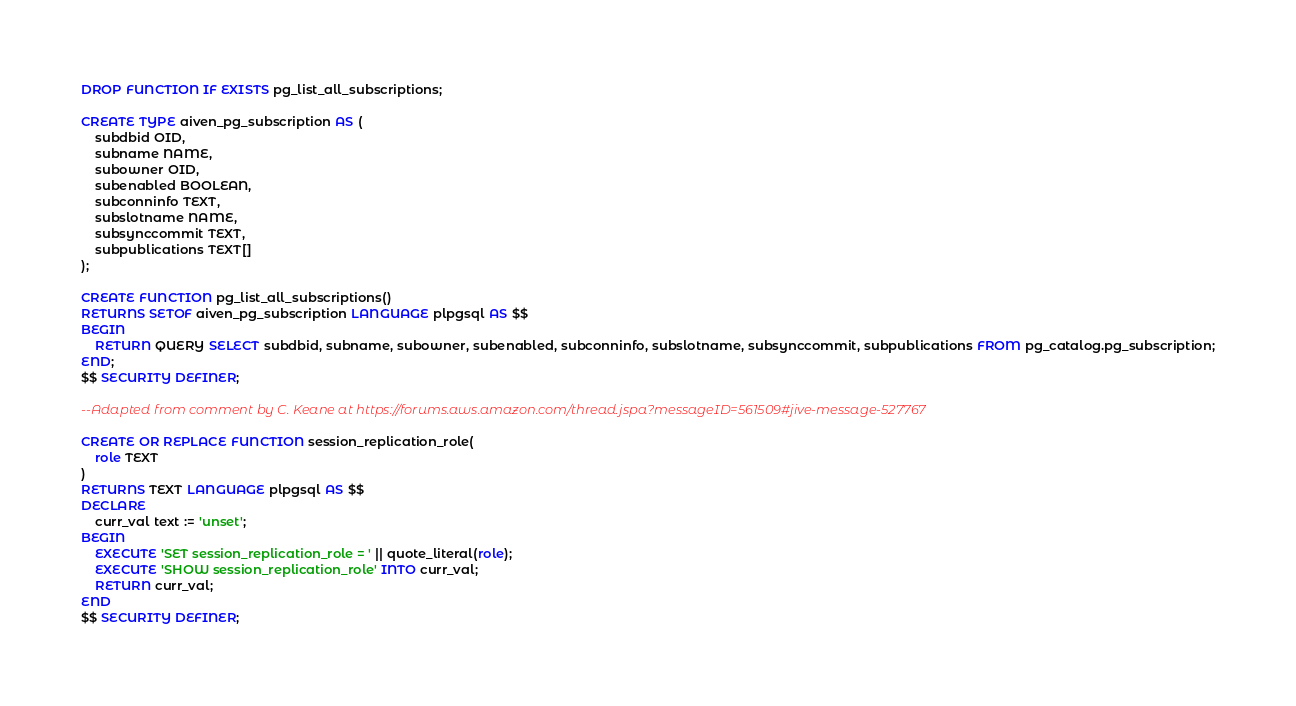<code> <loc_0><loc_0><loc_500><loc_500><_SQL_>DROP FUNCTION IF EXISTS pg_list_all_subscriptions;

CREATE TYPE aiven_pg_subscription AS (
    subdbid OID,
    subname NAME,
    subowner OID,
    subenabled BOOLEAN,
    subconninfo TEXT,
    subslotname NAME,
    subsynccommit TEXT,
    subpublications TEXT[]
);

CREATE FUNCTION pg_list_all_subscriptions()
RETURNS SETOF aiven_pg_subscription LANGUAGE plpgsql AS $$
BEGIN
    RETURN QUERY SELECT subdbid, subname, subowner, subenabled, subconninfo, subslotname, subsynccommit, subpublications FROM pg_catalog.pg_subscription;
END;
$$ SECURITY DEFINER;

--Adapted from comment by C. Keane at https://forums.aws.amazon.com/thread.jspa?messageID=561509#jive-message-527767

CREATE OR REPLACE FUNCTION session_replication_role(
    role TEXT
)
RETURNS TEXT LANGUAGE plpgsql AS $$
DECLARE
    curr_val text := 'unset';
BEGIN
    EXECUTE 'SET session_replication_role = ' || quote_literal(role);
    EXECUTE 'SHOW session_replication_role' INTO curr_val;
    RETURN curr_val;
END
$$ SECURITY DEFINER;
</code> 